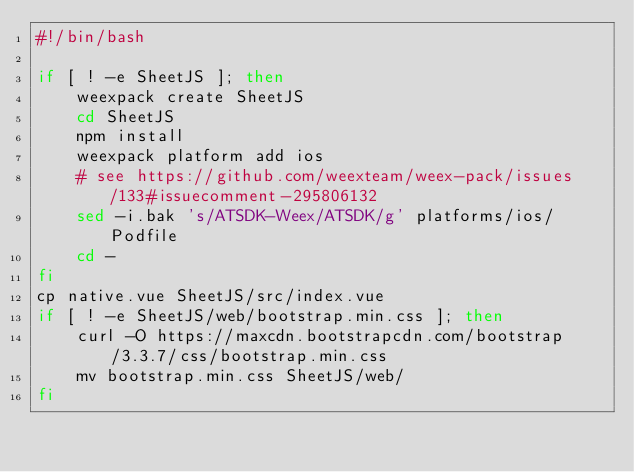Convert code to text. <code><loc_0><loc_0><loc_500><loc_500><_Bash_>#!/bin/bash

if [ ! -e SheetJS ]; then
	weexpack create SheetJS
	cd SheetJS
	npm install
	weexpack platform add ios
	# see https://github.com/weexteam/weex-pack/issues/133#issuecomment-295806132
	sed -i.bak 's/ATSDK-Weex/ATSDK/g' platforms/ios/Podfile
	cd -
fi
cp native.vue SheetJS/src/index.vue
if [ ! -e SheetJS/web/bootstrap.min.css ]; then
	curl -O https://maxcdn.bootstrapcdn.com/bootstrap/3.3.7/css/bootstrap.min.css
	mv bootstrap.min.css SheetJS/web/
fi
</code> 